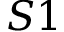Convert formula to latex. <formula><loc_0><loc_0><loc_500><loc_500>S 1</formula> 